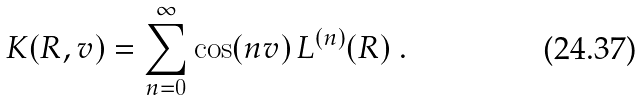Convert formula to latex. <formula><loc_0><loc_0><loc_500><loc_500>K ( R , v ) = \sum _ { n = 0 } ^ { \infty } \cos ( n v ) \, L ^ { ( n ) } ( R ) \ .</formula> 